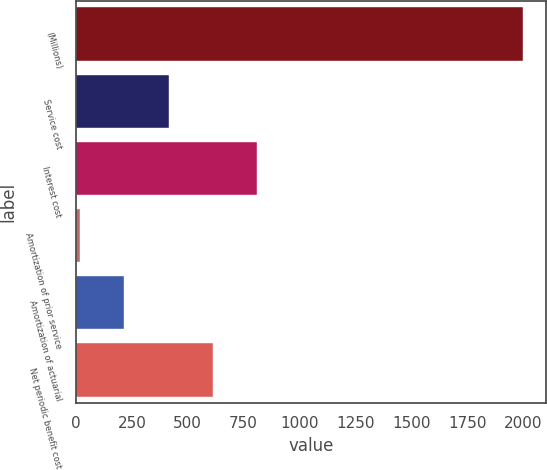Convert chart. <chart><loc_0><loc_0><loc_500><loc_500><bar_chart><fcel>(Millions)<fcel>Service cost<fcel>Interest cost<fcel>Amortization of prior service<fcel>Amortization of actuarial<fcel>Net periodic benefit cost<nl><fcel>2002<fcel>414.8<fcel>811.6<fcel>18<fcel>216.4<fcel>613.2<nl></chart> 